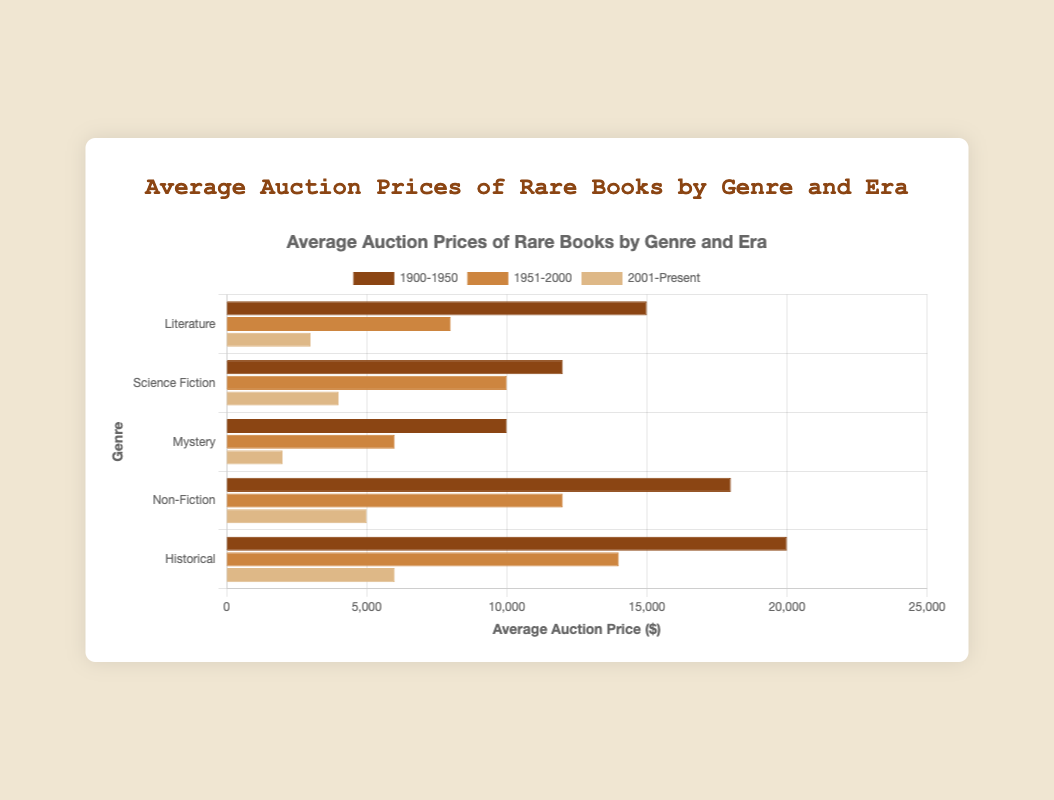What's the difference in average auction price between Literature and Science Fiction for the era 1900-1950? The average auction price for Literature (1900-1950) is $15,000, while for Science Fiction it's $12,000. The difference is 15,000 - 12,000.
Answer: $3,000 Which genre had the highest average auction price in the era 2001-Present? For the era 2001-Present, the average prices are: Literature ($3,000), Science Fiction ($4,000), Mystery ($2,000), Non-Fiction ($5,000), Historical ($6,000). The highest is Historical with $6,000.
Answer: Historical Which era had the lowest average auction price for Mystery books? The average auction prices for Mystery books are: 1900-1950 ($10,000), 1951-2000 ($6,000), 2001-Present ($2,000). The lowest is in the 2001-Present era with $2,000.
Answer: 2001-Present How much is the combined average auction price for Non-Fiction and Historical books in the era 1951-2000? The average auction price for Non-Fiction (1951-2000) is $12,000 and for Historical it's $14,000. The combined price is 12,000 + 14,000.
Answer: $26,000 Which genre shows the largest decrease in average auction price from the era 1900-1950 to 2001-Present? The decreases are: Literature ($15,000 to $3,000 = $12,000), Science Fiction ($12,000 to $4,000 = $8,000), Mystery ($10,000 to $2,000 = $8,000), Non-Fiction ($18,000 to $5,000 = $13,000), Historical ($20,000 to $6,000 = $14,000). The largest decrease is for Historical with a $14,000 drop.
Answer: Historical What is the average auction price of Science Fiction books across all eras? Science Fiction prices: 1900-1950 ($12,000), 1951-2000 ($10,000), 2001-Present ($4,000). The average is (12,000 + 10,000 + 4,000) / 3.
Answer: $8,667 Which bar(s) are colored differently when looking at the era 1951-2000? The bars for the eras are colored differently: 1900-1950 (dark brown), 1951-2000 (medium brown), 2001-Present (light brown). Bars colored medium brown represent the era 1951-2000.
Answer: Medium brown Is the average auction price for Non-Fiction books higher in the era 1951-2000 compared to Literature books in the same era? The average auction price for Non-Fiction (1951-2000) is $12,000, while for Literature it is $8,000. Non-Fiction is higher.
Answer: Yes 